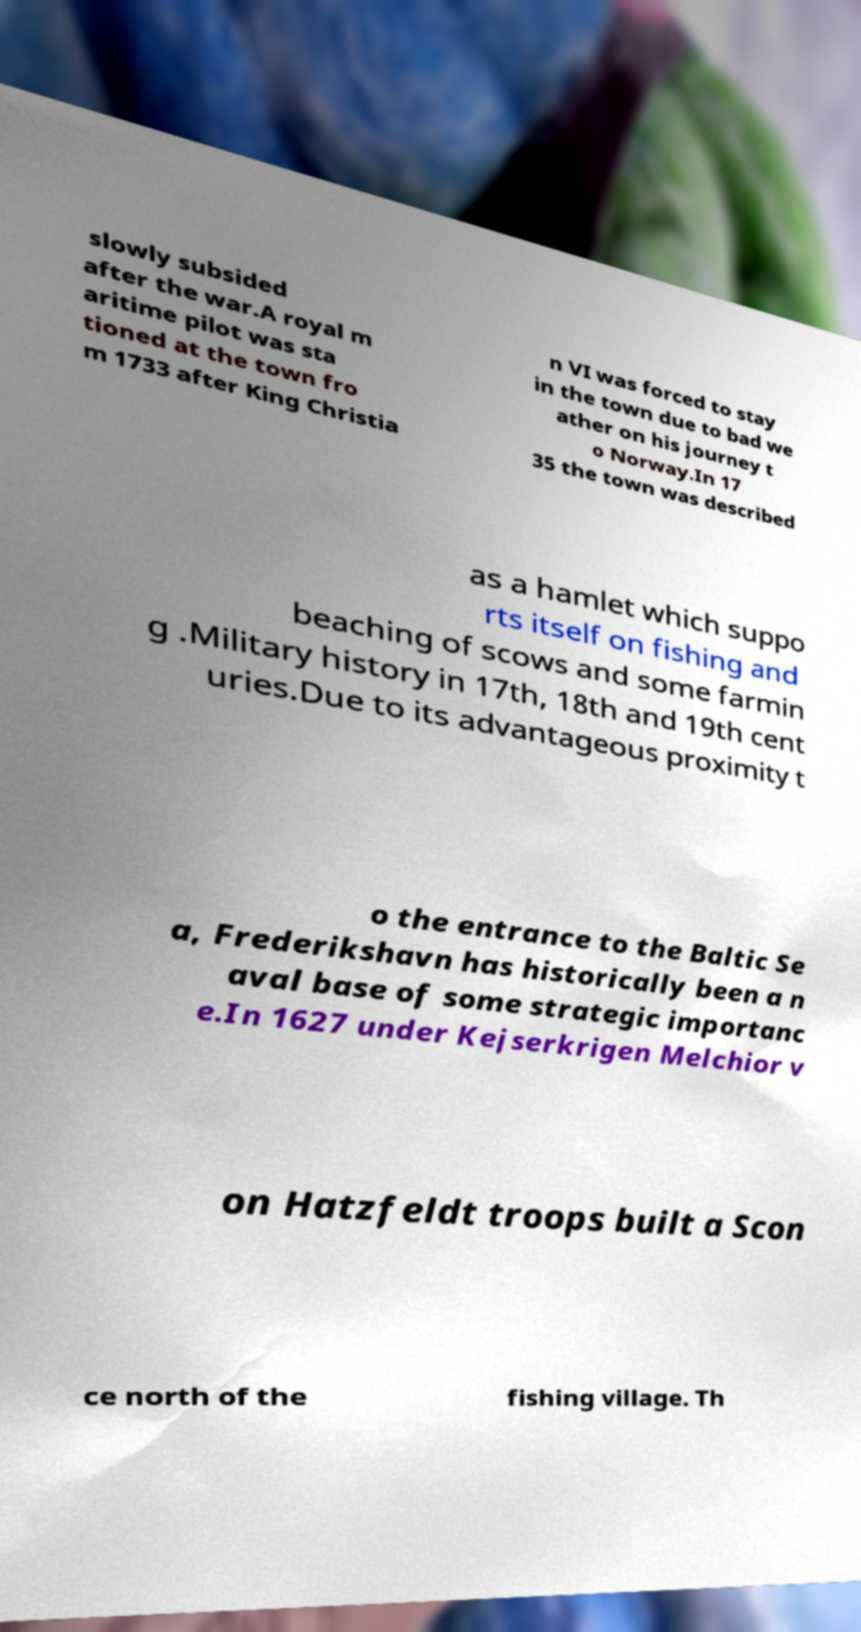For documentation purposes, I need the text within this image transcribed. Could you provide that? slowly subsided after the war.A royal m aritime pilot was sta tioned at the town fro m 1733 after King Christia n VI was forced to stay in the town due to bad we ather on his journey t o Norway.In 17 35 the town was described as a hamlet which suppo rts itself on fishing and beaching of scows and some farmin g .Military history in 17th, 18th and 19th cent uries.Due to its advantageous proximity t o the entrance to the Baltic Se a, Frederikshavn has historically been a n aval base of some strategic importanc e.In 1627 under Kejserkrigen Melchior v on Hatzfeldt troops built a Scon ce north of the fishing village. Th 